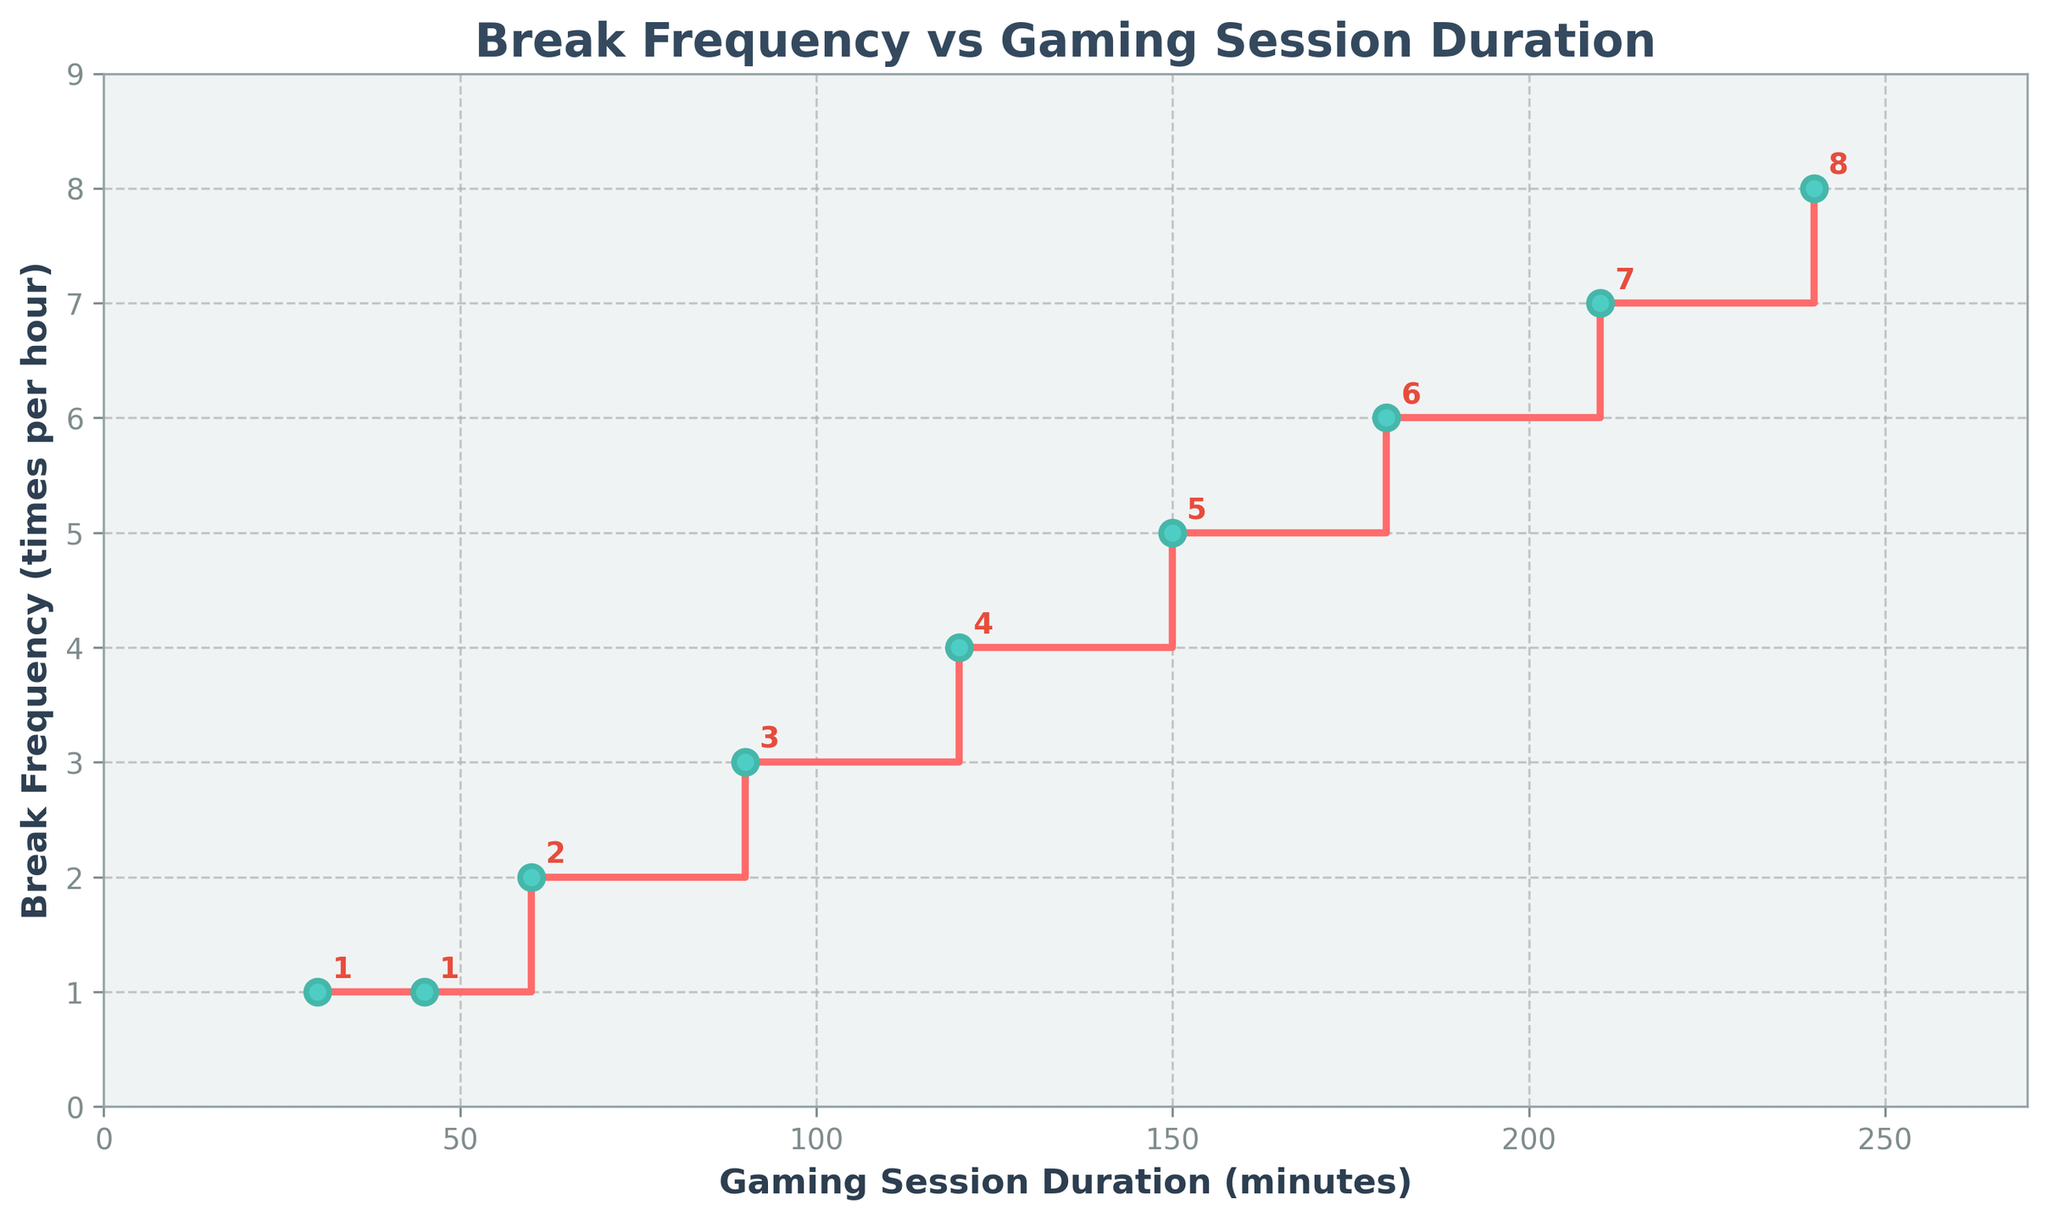What's the title of the figure? The title is displayed at the top of the figure. It is usually in a larger font and might be bolded.
Answer: Break Frequency vs Gaming Session Duration What are the labels for the x and y axes? The labels for the axes are typically located along the axes themselves. The x-axis label is under the bottom axis while the y-axis label is beside the left axis.
Answer: Gaming Session Duration (minutes), Break Frequency (times per hour) For a gaming session lasting 120 minutes, how often should breaks be taken per hour? By finding the point where the duration is 120 minutes on the x-axis and checking the corresponding value on the y-axis, you can determine the frequency of breaks.
Answer: 4 times per hour What is the trend in the break frequency as gaming session duration increases? The step plot visually shows how the break frequency changes with the gaming session duration, indicating a pattern.
Answer: It increases What is the break frequency difference between a 60-minute and a 120-minute gaming session? First, locate the break frequencies for 60 and 120 minutes on the y-axis. Then, subtract the break frequency for 60 minutes from that for 120 minutes.
Answer: 2 times per hour How many breaks would you take in total during a 90-minute gaming session? Multiply the break frequency for 90 minutes by 1.5 (as it is 1.5 hours).
Answer: 4.5 breaks Between which durations does the break frequency first increase to 3 times per hour? Identify the x-axis values where the y-axis first reaches 3. Check the range between the previous duration and this duration.
Answer: Between 60 and 90 minutes For which gaming session duration is the break frequency 7 times per hour? Find the value on the y-axis that matches 7 and trace horizontally to the corresponding x-axis value.
Answer: 210 minutes If you double the duration from 30 minutes to 60 minutes, how does the break frequency change? Double-check the break frequencies for 30 and 60 minutes. Compare the values to see how they differ.
Answer: It doubles from 1 to 2 times per hour How does the background color of the plot differ from the standard plot color you might expect? Observe the plot's background color. It is usually different from the standard white or plain backgrounds often used.
Answer: The background is light gray 